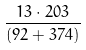<formula> <loc_0><loc_0><loc_500><loc_500>\frac { 1 3 \cdot 2 0 3 } { ( 9 2 + 3 7 4 ) }</formula> 